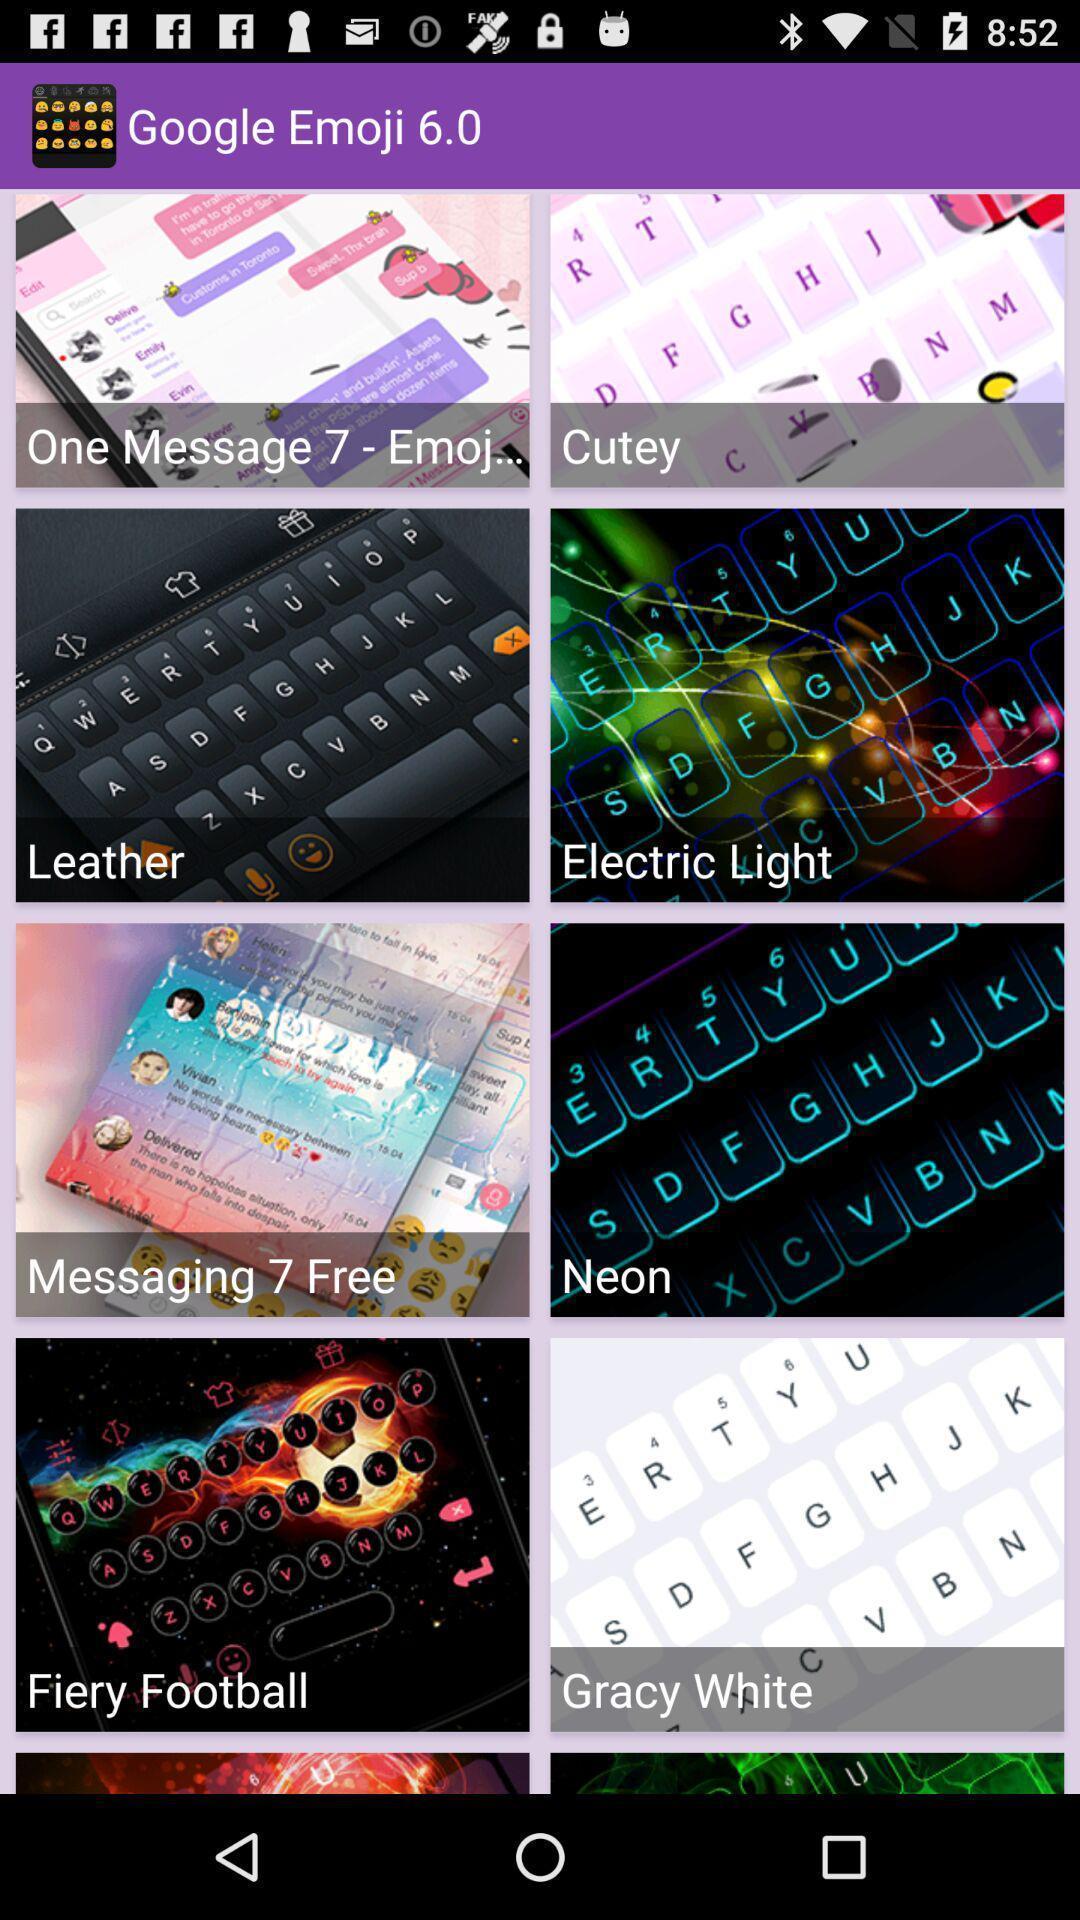Describe this image in words. Screen displaying screen page of emoji app. 